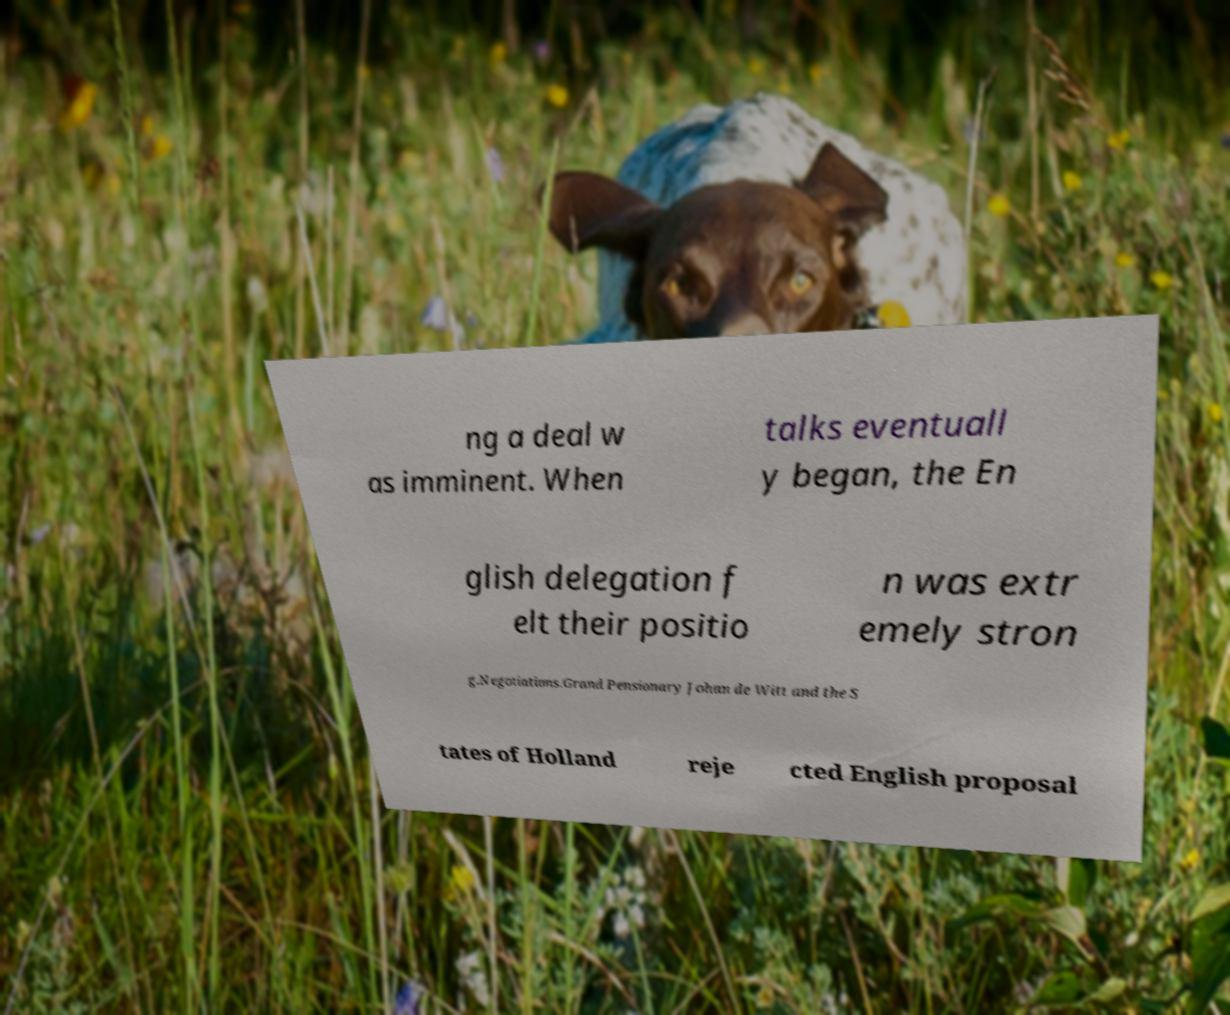Could you extract and type out the text from this image? ng a deal w as imminent. When talks eventuall y began, the En glish delegation f elt their positio n was extr emely stron g.Negotiations.Grand Pensionary Johan de Witt and the S tates of Holland reje cted English proposal 